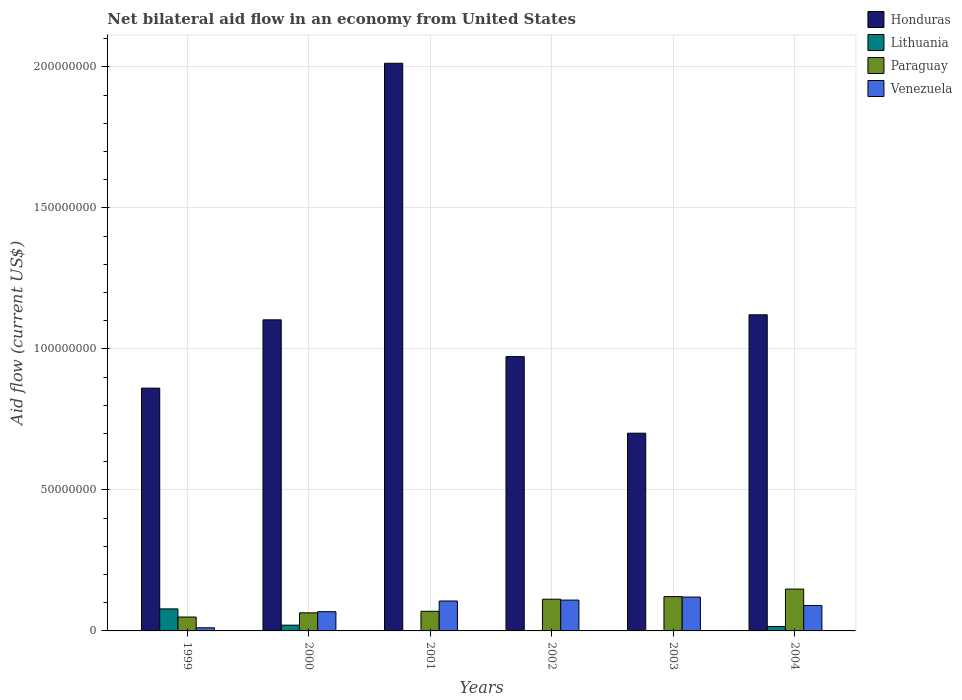How many groups of bars are there?
Make the answer very short. 6. Are the number of bars per tick equal to the number of legend labels?
Keep it short and to the point. No. How many bars are there on the 6th tick from the left?
Offer a very short reply. 4. How many bars are there on the 3rd tick from the right?
Offer a very short reply. 3. What is the label of the 1st group of bars from the left?
Your answer should be very brief. 1999. In how many cases, is the number of bars for a given year not equal to the number of legend labels?
Keep it short and to the point. 3. What is the net bilateral aid flow in Paraguay in 2004?
Keep it short and to the point. 1.48e+07. Across all years, what is the minimum net bilateral aid flow in Paraguay?
Your answer should be very brief. 4.93e+06. In which year was the net bilateral aid flow in Venezuela maximum?
Provide a short and direct response. 2003. What is the total net bilateral aid flow in Lithuania in the graph?
Offer a very short reply. 1.14e+07. What is the difference between the net bilateral aid flow in Venezuela in 2001 and that in 2003?
Your answer should be very brief. -1.39e+06. What is the difference between the net bilateral aid flow in Paraguay in 2000 and the net bilateral aid flow in Venezuela in 1999?
Offer a very short reply. 5.30e+06. What is the average net bilateral aid flow in Paraguay per year?
Offer a very short reply. 9.42e+06. In the year 1999, what is the difference between the net bilateral aid flow in Venezuela and net bilateral aid flow in Lithuania?
Your response must be concise. -6.70e+06. In how many years, is the net bilateral aid flow in Venezuela greater than 100000000 US$?
Your response must be concise. 0. What is the ratio of the net bilateral aid flow in Venezuela in 1999 to that in 2004?
Offer a terse response. 0.12. Is the net bilateral aid flow in Venezuela in 2000 less than that in 2003?
Make the answer very short. Yes. Is the difference between the net bilateral aid flow in Venezuela in 1999 and 2004 greater than the difference between the net bilateral aid flow in Lithuania in 1999 and 2004?
Your response must be concise. No. What is the difference between the highest and the second highest net bilateral aid flow in Venezuela?
Provide a short and direct response. 1.07e+06. What is the difference between the highest and the lowest net bilateral aid flow in Venezuela?
Give a very brief answer. 1.09e+07. Is the sum of the net bilateral aid flow in Paraguay in 1999 and 2000 greater than the maximum net bilateral aid flow in Honduras across all years?
Make the answer very short. No. Is it the case that in every year, the sum of the net bilateral aid flow in Paraguay and net bilateral aid flow in Venezuela is greater than the sum of net bilateral aid flow in Lithuania and net bilateral aid flow in Honduras?
Offer a very short reply. No. Is it the case that in every year, the sum of the net bilateral aid flow in Venezuela and net bilateral aid flow in Lithuania is greater than the net bilateral aid flow in Paraguay?
Make the answer very short. No. Are all the bars in the graph horizontal?
Ensure brevity in your answer.  No. How many years are there in the graph?
Offer a terse response. 6. Does the graph contain grids?
Your answer should be very brief. Yes. How many legend labels are there?
Offer a terse response. 4. What is the title of the graph?
Ensure brevity in your answer.  Net bilateral aid flow in an economy from United States. What is the label or title of the X-axis?
Offer a terse response. Years. What is the label or title of the Y-axis?
Keep it short and to the point. Aid flow (current US$). What is the Aid flow (current US$) of Honduras in 1999?
Give a very brief answer. 8.61e+07. What is the Aid flow (current US$) of Lithuania in 1999?
Provide a short and direct response. 7.81e+06. What is the Aid flow (current US$) in Paraguay in 1999?
Make the answer very short. 4.93e+06. What is the Aid flow (current US$) in Venezuela in 1999?
Offer a very short reply. 1.11e+06. What is the Aid flow (current US$) of Honduras in 2000?
Keep it short and to the point. 1.10e+08. What is the Aid flow (current US$) of Lithuania in 2000?
Offer a terse response. 2.04e+06. What is the Aid flow (current US$) of Paraguay in 2000?
Provide a succinct answer. 6.41e+06. What is the Aid flow (current US$) in Venezuela in 2000?
Your answer should be very brief. 6.82e+06. What is the Aid flow (current US$) of Honduras in 2001?
Your answer should be very brief. 2.01e+08. What is the Aid flow (current US$) of Paraguay in 2001?
Your response must be concise. 6.96e+06. What is the Aid flow (current US$) of Venezuela in 2001?
Your answer should be very brief. 1.06e+07. What is the Aid flow (current US$) in Honduras in 2002?
Your answer should be very brief. 9.72e+07. What is the Aid flow (current US$) in Paraguay in 2002?
Keep it short and to the point. 1.12e+07. What is the Aid flow (current US$) of Venezuela in 2002?
Provide a short and direct response. 1.09e+07. What is the Aid flow (current US$) in Honduras in 2003?
Ensure brevity in your answer.  7.01e+07. What is the Aid flow (current US$) in Paraguay in 2003?
Ensure brevity in your answer.  1.22e+07. What is the Aid flow (current US$) in Honduras in 2004?
Your answer should be compact. 1.12e+08. What is the Aid flow (current US$) of Lithuania in 2004?
Your response must be concise. 1.58e+06. What is the Aid flow (current US$) of Paraguay in 2004?
Provide a short and direct response. 1.48e+07. What is the Aid flow (current US$) in Venezuela in 2004?
Ensure brevity in your answer.  9.00e+06. Across all years, what is the maximum Aid flow (current US$) of Honduras?
Give a very brief answer. 2.01e+08. Across all years, what is the maximum Aid flow (current US$) of Lithuania?
Offer a very short reply. 7.81e+06. Across all years, what is the maximum Aid flow (current US$) in Paraguay?
Provide a succinct answer. 1.48e+07. Across all years, what is the minimum Aid flow (current US$) of Honduras?
Your answer should be very brief. 7.01e+07. Across all years, what is the minimum Aid flow (current US$) in Lithuania?
Make the answer very short. 0. Across all years, what is the minimum Aid flow (current US$) in Paraguay?
Offer a very short reply. 4.93e+06. Across all years, what is the minimum Aid flow (current US$) of Venezuela?
Make the answer very short. 1.11e+06. What is the total Aid flow (current US$) in Honduras in the graph?
Offer a very short reply. 6.77e+08. What is the total Aid flow (current US$) in Lithuania in the graph?
Ensure brevity in your answer.  1.14e+07. What is the total Aid flow (current US$) in Paraguay in the graph?
Offer a very short reply. 5.65e+07. What is the total Aid flow (current US$) in Venezuela in the graph?
Offer a terse response. 5.05e+07. What is the difference between the Aid flow (current US$) in Honduras in 1999 and that in 2000?
Provide a succinct answer. -2.42e+07. What is the difference between the Aid flow (current US$) of Lithuania in 1999 and that in 2000?
Keep it short and to the point. 5.77e+06. What is the difference between the Aid flow (current US$) of Paraguay in 1999 and that in 2000?
Offer a terse response. -1.48e+06. What is the difference between the Aid flow (current US$) in Venezuela in 1999 and that in 2000?
Make the answer very short. -5.71e+06. What is the difference between the Aid flow (current US$) of Honduras in 1999 and that in 2001?
Give a very brief answer. -1.15e+08. What is the difference between the Aid flow (current US$) of Paraguay in 1999 and that in 2001?
Provide a short and direct response. -2.03e+06. What is the difference between the Aid flow (current US$) in Venezuela in 1999 and that in 2001?
Ensure brevity in your answer.  -9.50e+06. What is the difference between the Aid flow (current US$) in Honduras in 1999 and that in 2002?
Offer a very short reply. -1.12e+07. What is the difference between the Aid flow (current US$) in Paraguay in 1999 and that in 2002?
Your answer should be very brief. -6.31e+06. What is the difference between the Aid flow (current US$) of Venezuela in 1999 and that in 2002?
Your response must be concise. -9.82e+06. What is the difference between the Aid flow (current US$) in Honduras in 1999 and that in 2003?
Keep it short and to the point. 1.60e+07. What is the difference between the Aid flow (current US$) in Paraguay in 1999 and that in 2003?
Keep it short and to the point. -7.24e+06. What is the difference between the Aid flow (current US$) in Venezuela in 1999 and that in 2003?
Ensure brevity in your answer.  -1.09e+07. What is the difference between the Aid flow (current US$) in Honduras in 1999 and that in 2004?
Give a very brief answer. -2.60e+07. What is the difference between the Aid flow (current US$) in Lithuania in 1999 and that in 2004?
Make the answer very short. 6.23e+06. What is the difference between the Aid flow (current US$) in Paraguay in 1999 and that in 2004?
Ensure brevity in your answer.  -9.90e+06. What is the difference between the Aid flow (current US$) in Venezuela in 1999 and that in 2004?
Keep it short and to the point. -7.89e+06. What is the difference between the Aid flow (current US$) of Honduras in 2000 and that in 2001?
Your response must be concise. -9.10e+07. What is the difference between the Aid flow (current US$) of Paraguay in 2000 and that in 2001?
Your answer should be very brief. -5.50e+05. What is the difference between the Aid flow (current US$) in Venezuela in 2000 and that in 2001?
Your answer should be very brief. -3.79e+06. What is the difference between the Aid flow (current US$) of Honduras in 2000 and that in 2002?
Offer a very short reply. 1.30e+07. What is the difference between the Aid flow (current US$) in Paraguay in 2000 and that in 2002?
Your answer should be very brief. -4.83e+06. What is the difference between the Aid flow (current US$) of Venezuela in 2000 and that in 2002?
Keep it short and to the point. -4.11e+06. What is the difference between the Aid flow (current US$) in Honduras in 2000 and that in 2003?
Your answer should be very brief. 4.02e+07. What is the difference between the Aid flow (current US$) in Paraguay in 2000 and that in 2003?
Ensure brevity in your answer.  -5.76e+06. What is the difference between the Aid flow (current US$) of Venezuela in 2000 and that in 2003?
Your response must be concise. -5.18e+06. What is the difference between the Aid flow (current US$) of Honduras in 2000 and that in 2004?
Offer a terse response. -1.79e+06. What is the difference between the Aid flow (current US$) in Paraguay in 2000 and that in 2004?
Provide a succinct answer. -8.42e+06. What is the difference between the Aid flow (current US$) in Venezuela in 2000 and that in 2004?
Your answer should be compact. -2.18e+06. What is the difference between the Aid flow (current US$) of Honduras in 2001 and that in 2002?
Provide a short and direct response. 1.04e+08. What is the difference between the Aid flow (current US$) in Paraguay in 2001 and that in 2002?
Offer a very short reply. -4.28e+06. What is the difference between the Aid flow (current US$) of Venezuela in 2001 and that in 2002?
Offer a very short reply. -3.20e+05. What is the difference between the Aid flow (current US$) of Honduras in 2001 and that in 2003?
Provide a succinct answer. 1.31e+08. What is the difference between the Aid flow (current US$) in Paraguay in 2001 and that in 2003?
Keep it short and to the point. -5.21e+06. What is the difference between the Aid flow (current US$) in Venezuela in 2001 and that in 2003?
Provide a short and direct response. -1.39e+06. What is the difference between the Aid flow (current US$) of Honduras in 2001 and that in 2004?
Your answer should be very brief. 8.92e+07. What is the difference between the Aid flow (current US$) of Paraguay in 2001 and that in 2004?
Provide a short and direct response. -7.87e+06. What is the difference between the Aid flow (current US$) of Venezuela in 2001 and that in 2004?
Your answer should be compact. 1.61e+06. What is the difference between the Aid flow (current US$) in Honduras in 2002 and that in 2003?
Give a very brief answer. 2.71e+07. What is the difference between the Aid flow (current US$) of Paraguay in 2002 and that in 2003?
Your answer should be compact. -9.30e+05. What is the difference between the Aid flow (current US$) in Venezuela in 2002 and that in 2003?
Your answer should be compact. -1.07e+06. What is the difference between the Aid flow (current US$) in Honduras in 2002 and that in 2004?
Your response must be concise. -1.48e+07. What is the difference between the Aid flow (current US$) in Paraguay in 2002 and that in 2004?
Your answer should be very brief. -3.59e+06. What is the difference between the Aid flow (current US$) of Venezuela in 2002 and that in 2004?
Make the answer very short. 1.93e+06. What is the difference between the Aid flow (current US$) of Honduras in 2003 and that in 2004?
Provide a short and direct response. -4.20e+07. What is the difference between the Aid flow (current US$) of Paraguay in 2003 and that in 2004?
Keep it short and to the point. -2.66e+06. What is the difference between the Aid flow (current US$) in Venezuela in 2003 and that in 2004?
Offer a very short reply. 3.00e+06. What is the difference between the Aid flow (current US$) of Honduras in 1999 and the Aid flow (current US$) of Lithuania in 2000?
Your answer should be compact. 8.40e+07. What is the difference between the Aid flow (current US$) of Honduras in 1999 and the Aid flow (current US$) of Paraguay in 2000?
Ensure brevity in your answer.  7.97e+07. What is the difference between the Aid flow (current US$) of Honduras in 1999 and the Aid flow (current US$) of Venezuela in 2000?
Your response must be concise. 7.93e+07. What is the difference between the Aid flow (current US$) in Lithuania in 1999 and the Aid flow (current US$) in Paraguay in 2000?
Provide a short and direct response. 1.40e+06. What is the difference between the Aid flow (current US$) of Lithuania in 1999 and the Aid flow (current US$) of Venezuela in 2000?
Offer a terse response. 9.90e+05. What is the difference between the Aid flow (current US$) of Paraguay in 1999 and the Aid flow (current US$) of Venezuela in 2000?
Your answer should be very brief. -1.89e+06. What is the difference between the Aid flow (current US$) of Honduras in 1999 and the Aid flow (current US$) of Paraguay in 2001?
Your answer should be very brief. 7.91e+07. What is the difference between the Aid flow (current US$) of Honduras in 1999 and the Aid flow (current US$) of Venezuela in 2001?
Offer a terse response. 7.55e+07. What is the difference between the Aid flow (current US$) of Lithuania in 1999 and the Aid flow (current US$) of Paraguay in 2001?
Offer a very short reply. 8.50e+05. What is the difference between the Aid flow (current US$) in Lithuania in 1999 and the Aid flow (current US$) in Venezuela in 2001?
Your response must be concise. -2.80e+06. What is the difference between the Aid flow (current US$) in Paraguay in 1999 and the Aid flow (current US$) in Venezuela in 2001?
Provide a short and direct response. -5.68e+06. What is the difference between the Aid flow (current US$) of Honduras in 1999 and the Aid flow (current US$) of Paraguay in 2002?
Keep it short and to the point. 7.48e+07. What is the difference between the Aid flow (current US$) of Honduras in 1999 and the Aid flow (current US$) of Venezuela in 2002?
Give a very brief answer. 7.52e+07. What is the difference between the Aid flow (current US$) in Lithuania in 1999 and the Aid flow (current US$) in Paraguay in 2002?
Make the answer very short. -3.43e+06. What is the difference between the Aid flow (current US$) in Lithuania in 1999 and the Aid flow (current US$) in Venezuela in 2002?
Ensure brevity in your answer.  -3.12e+06. What is the difference between the Aid flow (current US$) of Paraguay in 1999 and the Aid flow (current US$) of Venezuela in 2002?
Offer a terse response. -6.00e+06. What is the difference between the Aid flow (current US$) of Honduras in 1999 and the Aid flow (current US$) of Paraguay in 2003?
Give a very brief answer. 7.39e+07. What is the difference between the Aid flow (current US$) of Honduras in 1999 and the Aid flow (current US$) of Venezuela in 2003?
Your response must be concise. 7.41e+07. What is the difference between the Aid flow (current US$) in Lithuania in 1999 and the Aid flow (current US$) in Paraguay in 2003?
Ensure brevity in your answer.  -4.36e+06. What is the difference between the Aid flow (current US$) of Lithuania in 1999 and the Aid flow (current US$) of Venezuela in 2003?
Keep it short and to the point. -4.19e+06. What is the difference between the Aid flow (current US$) of Paraguay in 1999 and the Aid flow (current US$) of Venezuela in 2003?
Offer a terse response. -7.07e+06. What is the difference between the Aid flow (current US$) of Honduras in 1999 and the Aid flow (current US$) of Lithuania in 2004?
Provide a short and direct response. 8.45e+07. What is the difference between the Aid flow (current US$) of Honduras in 1999 and the Aid flow (current US$) of Paraguay in 2004?
Make the answer very short. 7.12e+07. What is the difference between the Aid flow (current US$) in Honduras in 1999 and the Aid flow (current US$) in Venezuela in 2004?
Provide a short and direct response. 7.71e+07. What is the difference between the Aid flow (current US$) in Lithuania in 1999 and the Aid flow (current US$) in Paraguay in 2004?
Provide a short and direct response. -7.02e+06. What is the difference between the Aid flow (current US$) in Lithuania in 1999 and the Aid flow (current US$) in Venezuela in 2004?
Ensure brevity in your answer.  -1.19e+06. What is the difference between the Aid flow (current US$) in Paraguay in 1999 and the Aid flow (current US$) in Venezuela in 2004?
Offer a terse response. -4.07e+06. What is the difference between the Aid flow (current US$) in Honduras in 2000 and the Aid flow (current US$) in Paraguay in 2001?
Your answer should be very brief. 1.03e+08. What is the difference between the Aid flow (current US$) of Honduras in 2000 and the Aid flow (current US$) of Venezuela in 2001?
Keep it short and to the point. 9.97e+07. What is the difference between the Aid flow (current US$) in Lithuania in 2000 and the Aid flow (current US$) in Paraguay in 2001?
Provide a short and direct response. -4.92e+06. What is the difference between the Aid flow (current US$) in Lithuania in 2000 and the Aid flow (current US$) in Venezuela in 2001?
Provide a succinct answer. -8.57e+06. What is the difference between the Aid flow (current US$) in Paraguay in 2000 and the Aid flow (current US$) in Venezuela in 2001?
Make the answer very short. -4.20e+06. What is the difference between the Aid flow (current US$) of Honduras in 2000 and the Aid flow (current US$) of Paraguay in 2002?
Offer a terse response. 9.90e+07. What is the difference between the Aid flow (current US$) of Honduras in 2000 and the Aid flow (current US$) of Venezuela in 2002?
Ensure brevity in your answer.  9.94e+07. What is the difference between the Aid flow (current US$) in Lithuania in 2000 and the Aid flow (current US$) in Paraguay in 2002?
Your answer should be compact. -9.20e+06. What is the difference between the Aid flow (current US$) of Lithuania in 2000 and the Aid flow (current US$) of Venezuela in 2002?
Offer a terse response. -8.89e+06. What is the difference between the Aid flow (current US$) of Paraguay in 2000 and the Aid flow (current US$) of Venezuela in 2002?
Offer a terse response. -4.52e+06. What is the difference between the Aid flow (current US$) in Honduras in 2000 and the Aid flow (current US$) in Paraguay in 2003?
Provide a short and direct response. 9.81e+07. What is the difference between the Aid flow (current US$) of Honduras in 2000 and the Aid flow (current US$) of Venezuela in 2003?
Provide a succinct answer. 9.83e+07. What is the difference between the Aid flow (current US$) in Lithuania in 2000 and the Aid flow (current US$) in Paraguay in 2003?
Your answer should be very brief. -1.01e+07. What is the difference between the Aid flow (current US$) of Lithuania in 2000 and the Aid flow (current US$) of Venezuela in 2003?
Your response must be concise. -9.96e+06. What is the difference between the Aid flow (current US$) in Paraguay in 2000 and the Aid flow (current US$) in Venezuela in 2003?
Provide a short and direct response. -5.59e+06. What is the difference between the Aid flow (current US$) of Honduras in 2000 and the Aid flow (current US$) of Lithuania in 2004?
Offer a very short reply. 1.09e+08. What is the difference between the Aid flow (current US$) in Honduras in 2000 and the Aid flow (current US$) in Paraguay in 2004?
Keep it short and to the point. 9.55e+07. What is the difference between the Aid flow (current US$) in Honduras in 2000 and the Aid flow (current US$) in Venezuela in 2004?
Provide a succinct answer. 1.01e+08. What is the difference between the Aid flow (current US$) in Lithuania in 2000 and the Aid flow (current US$) in Paraguay in 2004?
Your answer should be very brief. -1.28e+07. What is the difference between the Aid flow (current US$) of Lithuania in 2000 and the Aid flow (current US$) of Venezuela in 2004?
Your response must be concise. -6.96e+06. What is the difference between the Aid flow (current US$) in Paraguay in 2000 and the Aid flow (current US$) in Venezuela in 2004?
Your response must be concise. -2.59e+06. What is the difference between the Aid flow (current US$) in Honduras in 2001 and the Aid flow (current US$) in Paraguay in 2002?
Provide a short and direct response. 1.90e+08. What is the difference between the Aid flow (current US$) in Honduras in 2001 and the Aid flow (current US$) in Venezuela in 2002?
Provide a succinct answer. 1.90e+08. What is the difference between the Aid flow (current US$) in Paraguay in 2001 and the Aid flow (current US$) in Venezuela in 2002?
Your response must be concise. -3.97e+06. What is the difference between the Aid flow (current US$) of Honduras in 2001 and the Aid flow (current US$) of Paraguay in 2003?
Give a very brief answer. 1.89e+08. What is the difference between the Aid flow (current US$) in Honduras in 2001 and the Aid flow (current US$) in Venezuela in 2003?
Give a very brief answer. 1.89e+08. What is the difference between the Aid flow (current US$) of Paraguay in 2001 and the Aid flow (current US$) of Venezuela in 2003?
Your answer should be very brief. -5.04e+06. What is the difference between the Aid flow (current US$) in Honduras in 2001 and the Aid flow (current US$) in Lithuania in 2004?
Make the answer very short. 2.00e+08. What is the difference between the Aid flow (current US$) in Honduras in 2001 and the Aid flow (current US$) in Paraguay in 2004?
Provide a short and direct response. 1.86e+08. What is the difference between the Aid flow (current US$) of Honduras in 2001 and the Aid flow (current US$) of Venezuela in 2004?
Provide a succinct answer. 1.92e+08. What is the difference between the Aid flow (current US$) in Paraguay in 2001 and the Aid flow (current US$) in Venezuela in 2004?
Offer a terse response. -2.04e+06. What is the difference between the Aid flow (current US$) in Honduras in 2002 and the Aid flow (current US$) in Paraguay in 2003?
Your answer should be compact. 8.51e+07. What is the difference between the Aid flow (current US$) of Honduras in 2002 and the Aid flow (current US$) of Venezuela in 2003?
Your response must be concise. 8.52e+07. What is the difference between the Aid flow (current US$) of Paraguay in 2002 and the Aid flow (current US$) of Venezuela in 2003?
Your answer should be compact. -7.60e+05. What is the difference between the Aid flow (current US$) in Honduras in 2002 and the Aid flow (current US$) in Lithuania in 2004?
Give a very brief answer. 9.57e+07. What is the difference between the Aid flow (current US$) of Honduras in 2002 and the Aid flow (current US$) of Paraguay in 2004?
Your answer should be very brief. 8.24e+07. What is the difference between the Aid flow (current US$) of Honduras in 2002 and the Aid flow (current US$) of Venezuela in 2004?
Your answer should be very brief. 8.82e+07. What is the difference between the Aid flow (current US$) of Paraguay in 2002 and the Aid flow (current US$) of Venezuela in 2004?
Provide a short and direct response. 2.24e+06. What is the difference between the Aid flow (current US$) in Honduras in 2003 and the Aid flow (current US$) in Lithuania in 2004?
Give a very brief answer. 6.85e+07. What is the difference between the Aid flow (current US$) in Honduras in 2003 and the Aid flow (current US$) in Paraguay in 2004?
Provide a short and direct response. 5.53e+07. What is the difference between the Aid flow (current US$) of Honduras in 2003 and the Aid flow (current US$) of Venezuela in 2004?
Provide a succinct answer. 6.11e+07. What is the difference between the Aid flow (current US$) in Paraguay in 2003 and the Aid flow (current US$) in Venezuela in 2004?
Provide a short and direct response. 3.17e+06. What is the average Aid flow (current US$) of Honduras per year?
Provide a succinct answer. 1.13e+08. What is the average Aid flow (current US$) of Lithuania per year?
Provide a short and direct response. 1.90e+06. What is the average Aid flow (current US$) in Paraguay per year?
Keep it short and to the point. 9.42e+06. What is the average Aid flow (current US$) of Venezuela per year?
Keep it short and to the point. 8.41e+06. In the year 1999, what is the difference between the Aid flow (current US$) in Honduras and Aid flow (current US$) in Lithuania?
Offer a terse response. 7.83e+07. In the year 1999, what is the difference between the Aid flow (current US$) of Honduras and Aid flow (current US$) of Paraguay?
Offer a terse response. 8.12e+07. In the year 1999, what is the difference between the Aid flow (current US$) in Honduras and Aid flow (current US$) in Venezuela?
Your answer should be compact. 8.50e+07. In the year 1999, what is the difference between the Aid flow (current US$) in Lithuania and Aid flow (current US$) in Paraguay?
Give a very brief answer. 2.88e+06. In the year 1999, what is the difference between the Aid flow (current US$) of Lithuania and Aid flow (current US$) of Venezuela?
Make the answer very short. 6.70e+06. In the year 1999, what is the difference between the Aid flow (current US$) in Paraguay and Aid flow (current US$) in Venezuela?
Your response must be concise. 3.82e+06. In the year 2000, what is the difference between the Aid flow (current US$) of Honduras and Aid flow (current US$) of Lithuania?
Offer a very short reply. 1.08e+08. In the year 2000, what is the difference between the Aid flow (current US$) in Honduras and Aid flow (current US$) in Paraguay?
Provide a succinct answer. 1.04e+08. In the year 2000, what is the difference between the Aid flow (current US$) of Honduras and Aid flow (current US$) of Venezuela?
Give a very brief answer. 1.03e+08. In the year 2000, what is the difference between the Aid flow (current US$) of Lithuania and Aid flow (current US$) of Paraguay?
Make the answer very short. -4.37e+06. In the year 2000, what is the difference between the Aid flow (current US$) of Lithuania and Aid flow (current US$) of Venezuela?
Offer a terse response. -4.78e+06. In the year 2000, what is the difference between the Aid flow (current US$) in Paraguay and Aid flow (current US$) in Venezuela?
Make the answer very short. -4.10e+05. In the year 2001, what is the difference between the Aid flow (current US$) in Honduras and Aid flow (current US$) in Paraguay?
Provide a succinct answer. 1.94e+08. In the year 2001, what is the difference between the Aid flow (current US$) of Honduras and Aid flow (current US$) of Venezuela?
Your response must be concise. 1.91e+08. In the year 2001, what is the difference between the Aid flow (current US$) in Paraguay and Aid flow (current US$) in Venezuela?
Ensure brevity in your answer.  -3.65e+06. In the year 2002, what is the difference between the Aid flow (current US$) in Honduras and Aid flow (current US$) in Paraguay?
Offer a terse response. 8.60e+07. In the year 2002, what is the difference between the Aid flow (current US$) of Honduras and Aid flow (current US$) of Venezuela?
Give a very brief answer. 8.63e+07. In the year 2003, what is the difference between the Aid flow (current US$) of Honduras and Aid flow (current US$) of Paraguay?
Make the answer very short. 5.79e+07. In the year 2003, what is the difference between the Aid flow (current US$) in Honduras and Aid flow (current US$) in Venezuela?
Ensure brevity in your answer.  5.81e+07. In the year 2003, what is the difference between the Aid flow (current US$) in Paraguay and Aid flow (current US$) in Venezuela?
Give a very brief answer. 1.70e+05. In the year 2004, what is the difference between the Aid flow (current US$) in Honduras and Aid flow (current US$) in Lithuania?
Provide a succinct answer. 1.10e+08. In the year 2004, what is the difference between the Aid flow (current US$) in Honduras and Aid flow (current US$) in Paraguay?
Make the answer very short. 9.72e+07. In the year 2004, what is the difference between the Aid flow (current US$) in Honduras and Aid flow (current US$) in Venezuela?
Offer a very short reply. 1.03e+08. In the year 2004, what is the difference between the Aid flow (current US$) in Lithuania and Aid flow (current US$) in Paraguay?
Your answer should be compact. -1.32e+07. In the year 2004, what is the difference between the Aid flow (current US$) in Lithuania and Aid flow (current US$) in Venezuela?
Keep it short and to the point. -7.42e+06. In the year 2004, what is the difference between the Aid flow (current US$) of Paraguay and Aid flow (current US$) of Venezuela?
Your answer should be compact. 5.83e+06. What is the ratio of the Aid flow (current US$) of Honduras in 1999 to that in 2000?
Your answer should be very brief. 0.78. What is the ratio of the Aid flow (current US$) of Lithuania in 1999 to that in 2000?
Ensure brevity in your answer.  3.83. What is the ratio of the Aid flow (current US$) of Paraguay in 1999 to that in 2000?
Your response must be concise. 0.77. What is the ratio of the Aid flow (current US$) of Venezuela in 1999 to that in 2000?
Give a very brief answer. 0.16. What is the ratio of the Aid flow (current US$) of Honduras in 1999 to that in 2001?
Offer a terse response. 0.43. What is the ratio of the Aid flow (current US$) in Paraguay in 1999 to that in 2001?
Ensure brevity in your answer.  0.71. What is the ratio of the Aid flow (current US$) in Venezuela in 1999 to that in 2001?
Make the answer very short. 0.1. What is the ratio of the Aid flow (current US$) in Honduras in 1999 to that in 2002?
Keep it short and to the point. 0.89. What is the ratio of the Aid flow (current US$) of Paraguay in 1999 to that in 2002?
Keep it short and to the point. 0.44. What is the ratio of the Aid flow (current US$) of Venezuela in 1999 to that in 2002?
Provide a succinct answer. 0.1. What is the ratio of the Aid flow (current US$) in Honduras in 1999 to that in 2003?
Your response must be concise. 1.23. What is the ratio of the Aid flow (current US$) of Paraguay in 1999 to that in 2003?
Offer a very short reply. 0.41. What is the ratio of the Aid flow (current US$) of Venezuela in 1999 to that in 2003?
Your answer should be compact. 0.09. What is the ratio of the Aid flow (current US$) in Honduras in 1999 to that in 2004?
Provide a succinct answer. 0.77. What is the ratio of the Aid flow (current US$) of Lithuania in 1999 to that in 2004?
Give a very brief answer. 4.94. What is the ratio of the Aid flow (current US$) in Paraguay in 1999 to that in 2004?
Provide a succinct answer. 0.33. What is the ratio of the Aid flow (current US$) of Venezuela in 1999 to that in 2004?
Keep it short and to the point. 0.12. What is the ratio of the Aid flow (current US$) of Honduras in 2000 to that in 2001?
Your answer should be very brief. 0.55. What is the ratio of the Aid flow (current US$) in Paraguay in 2000 to that in 2001?
Your response must be concise. 0.92. What is the ratio of the Aid flow (current US$) in Venezuela in 2000 to that in 2001?
Offer a terse response. 0.64. What is the ratio of the Aid flow (current US$) in Honduras in 2000 to that in 2002?
Make the answer very short. 1.13. What is the ratio of the Aid flow (current US$) of Paraguay in 2000 to that in 2002?
Make the answer very short. 0.57. What is the ratio of the Aid flow (current US$) of Venezuela in 2000 to that in 2002?
Provide a succinct answer. 0.62. What is the ratio of the Aid flow (current US$) in Honduras in 2000 to that in 2003?
Offer a very short reply. 1.57. What is the ratio of the Aid flow (current US$) in Paraguay in 2000 to that in 2003?
Provide a short and direct response. 0.53. What is the ratio of the Aid flow (current US$) of Venezuela in 2000 to that in 2003?
Give a very brief answer. 0.57. What is the ratio of the Aid flow (current US$) in Honduras in 2000 to that in 2004?
Offer a terse response. 0.98. What is the ratio of the Aid flow (current US$) of Lithuania in 2000 to that in 2004?
Provide a succinct answer. 1.29. What is the ratio of the Aid flow (current US$) of Paraguay in 2000 to that in 2004?
Your answer should be very brief. 0.43. What is the ratio of the Aid flow (current US$) in Venezuela in 2000 to that in 2004?
Provide a short and direct response. 0.76. What is the ratio of the Aid flow (current US$) of Honduras in 2001 to that in 2002?
Offer a terse response. 2.07. What is the ratio of the Aid flow (current US$) in Paraguay in 2001 to that in 2002?
Give a very brief answer. 0.62. What is the ratio of the Aid flow (current US$) of Venezuela in 2001 to that in 2002?
Your answer should be compact. 0.97. What is the ratio of the Aid flow (current US$) in Honduras in 2001 to that in 2003?
Keep it short and to the point. 2.87. What is the ratio of the Aid flow (current US$) of Paraguay in 2001 to that in 2003?
Your answer should be very brief. 0.57. What is the ratio of the Aid flow (current US$) of Venezuela in 2001 to that in 2003?
Offer a terse response. 0.88. What is the ratio of the Aid flow (current US$) of Honduras in 2001 to that in 2004?
Offer a terse response. 1.8. What is the ratio of the Aid flow (current US$) in Paraguay in 2001 to that in 2004?
Your answer should be very brief. 0.47. What is the ratio of the Aid flow (current US$) of Venezuela in 2001 to that in 2004?
Provide a short and direct response. 1.18. What is the ratio of the Aid flow (current US$) of Honduras in 2002 to that in 2003?
Your answer should be very brief. 1.39. What is the ratio of the Aid flow (current US$) in Paraguay in 2002 to that in 2003?
Make the answer very short. 0.92. What is the ratio of the Aid flow (current US$) of Venezuela in 2002 to that in 2003?
Offer a very short reply. 0.91. What is the ratio of the Aid flow (current US$) of Honduras in 2002 to that in 2004?
Offer a terse response. 0.87. What is the ratio of the Aid flow (current US$) in Paraguay in 2002 to that in 2004?
Your answer should be very brief. 0.76. What is the ratio of the Aid flow (current US$) in Venezuela in 2002 to that in 2004?
Your answer should be compact. 1.21. What is the ratio of the Aid flow (current US$) in Honduras in 2003 to that in 2004?
Make the answer very short. 0.63. What is the ratio of the Aid flow (current US$) of Paraguay in 2003 to that in 2004?
Make the answer very short. 0.82. What is the difference between the highest and the second highest Aid flow (current US$) of Honduras?
Your answer should be very brief. 8.92e+07. What is the difference between the highest and the second highest Aid flow (current US$) of Lithuania?
Your answer should be very brief. 5.77e+06. What is the difference between the highest and the second highest Aid flow (current US$) in Paraguay?
Offer a very short reply. 2.66e+06. What is the difference between the highest and the second highest Aid flow (current US$) in Venezuela?
Your response must be concise. 1.07e+06. What is the difference between the highest and the lowest Aid flow (current US$) of Honduras?
Give a very brief answer. 1.31e+08. What is the difference between the highest and the lowest Aid flow (current US$) in Lithuania?
Your answer should be very brief. 7.81e+06. What is the difference between the highest and the lowest Aid flow (current US$) of Paraguay?
Provide a short and direct response. 9.90e+06. What is the difference between the highest and the lowest Aid flow (current US$) of Venezuela?
Provide a short and direct response. 1.09e+07. 